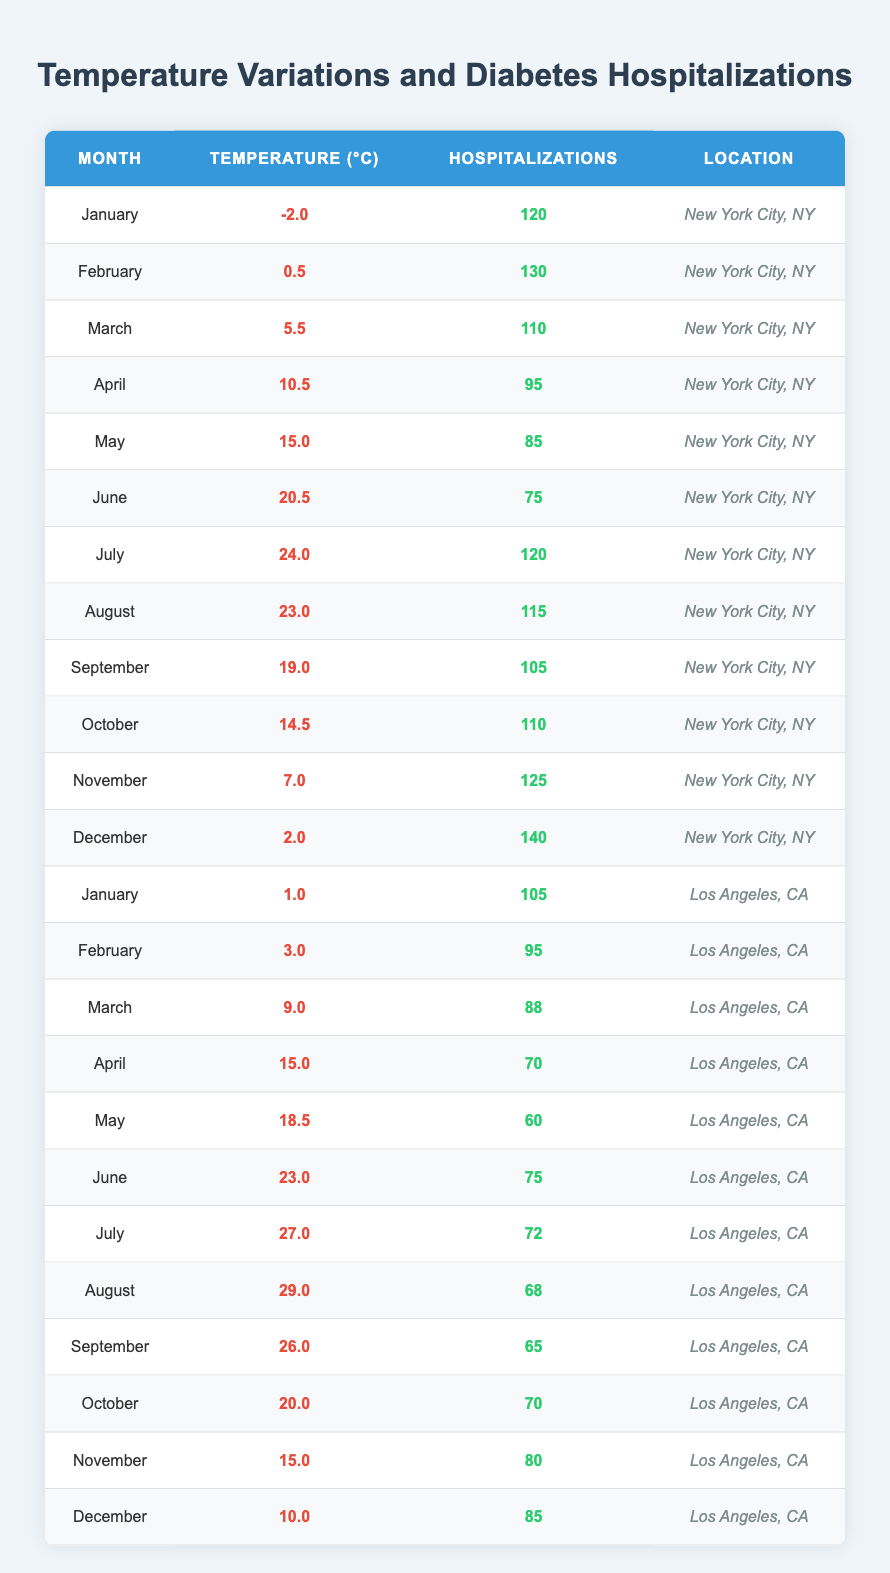What is the average temperature in July for New York City? The table shows the average temperature for New York City in July is 24.0 °C.
Answer: 24.0 °C How many hospitalizations were reported in December for Los Angeles? The table indicates that there were 85 hospitalizations reported in December for Los Angeles.
Answer: 85 Which month had the highest average temperature in Los Angeles? The table indicates August had the highest average temperature of 29.0 °C in Los Angeles.
Answer: 29.0 °C What is the difference in hospitalizations between January and February for New York City? In January, New York City had 120 hospitalizations and in February it had 130. The difference is 130 - 120 = 10.
Answer: 10 Is the average temperature in October for Los Angeles higher than that for New York City? The table states that the average temperature in October for Los Angeles is 20.0 °C and for New York City it is 14.5 °C. Since 20.0 > 14.5, the statement is true.
Answer: Yes What is the average number of hospitalizations over the year for New York City? To find the average for New York, sum the hospitalizations: 120 + 130 + 110 + 95 + 85 + 75 + 120 + 115 + 105 + 110 + 125 + 140 = 1,505. There are 12 months, so the average is 1,505 / 12 = approximately 125.42.
Answer: 125 Which month showed the lowest hospitalization rate for Los Angeles? The table shows that the lowest hospitalization rate for Los Angeles was in August, with 68 hospitalizations.
Answer: 68 How do the average temperatures of January and December compare for New York City? For January, the average temperature is -2.0 °C and for December it is 2.0 °C. Comparing -2.0 and 2.0, December is warmer by 4.0 °C.
Answer: December is warmer by 4.0 °C What is the total number of hospitalizations for both cities in May? In May, New York City had 85 hospitalizations and Los Angeles had 60. Therefore, total hospitalizations = 85 + 60 = 145.
Answer: 145 What is the average hospitalization rate for both cities during the summer months (June to August)? Calculate summer months' hospitalizations: For New York: 75 (June) + 120 (July) + 115 (August) = 310. For Los Angeles: 75 (June) + 72 (July) + 68 (August) = 215. Combined total is 310 + 215 = 525, with 6 data points, so average = 525 / 6 = 87.5.
Answer: 87.5 